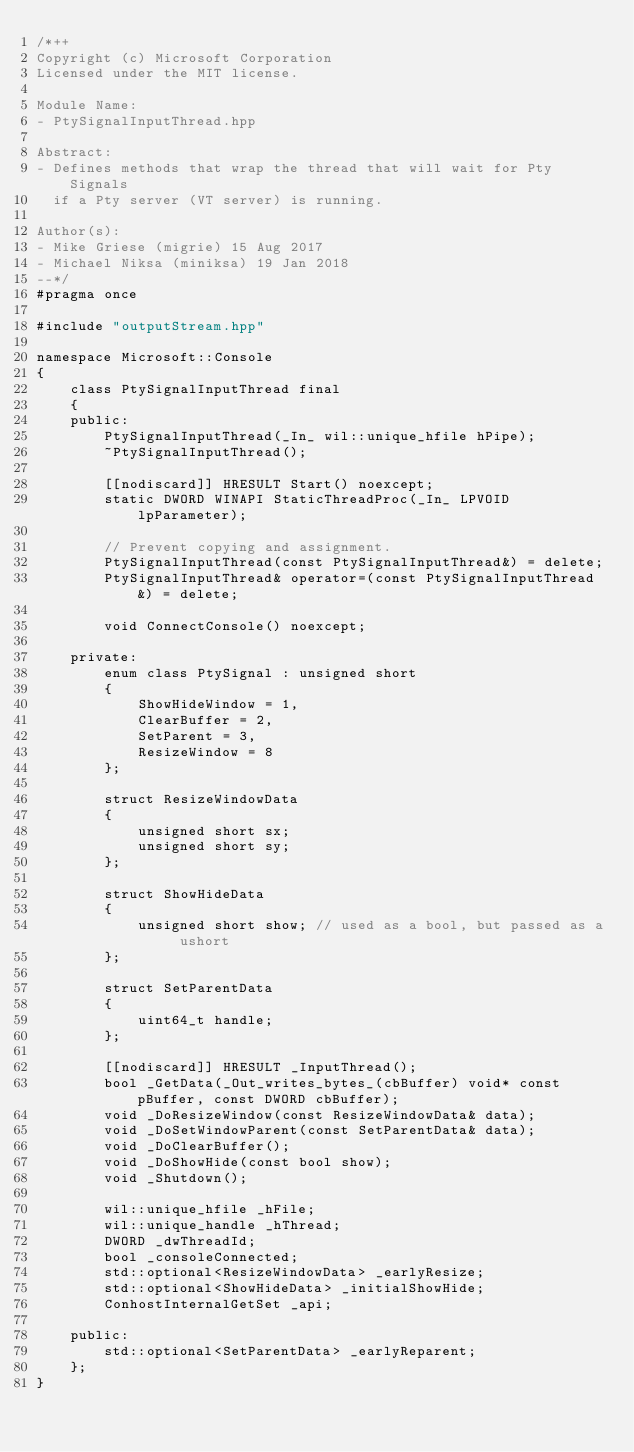Convert code to text. <code><loc_0><loc_0><loc_500><loc_500><_C++_>/*++
Copyright (c) Microsoft Corporation
Licensed under the MIT license.

Module Name:
- PtySignalInputThread.hpp

Abstract:
- Defines methods that wrap the thread that will wait for Pty Signals
  if a Pty server (VT server) is running.

Author(s):
- Mike Griese (migrie) 15 Aug 2017
- Michael Niksa (miniksa) 19 Jan 2018
--*/
#pragma once

#include "outputStream.hpp"

namespace Microsoft::Console
{
    class PtySignalInputThread final
    {
    public:
        PtySignalInputThread(_In_ wil::unique_hfile hPipe);
        ~PtySignalInputThread();

        [[nodiscard]] HRESULT Start() noexcept;
        static DWORD WINAPI StaticThreadProc(_In_ LPVOID lpParameter);

        // Prevent copying and assignment.
        PtySignalInputThread(const PtySignalInputThread&) = delete;
        PtySignalInputThread& operator=(const PtySignalInputThread&) = delete;

        void ConnectConsole() noexcept;

    private:
        enum class PtySignal : unsigned short
        {
            ShowHideWindow = 1,
            ClearBuffer = 2,
            SetParent = 3,
            ResizeWindow = 8
        };

        struct ResizeWindowData
        {
            unsigned short sx;
            unsigned short sy;
        };

        struct ShowHideData
        {
            unsigned short show; // used as a bool, but passed as a ushort
        };

        struct SetParentData
        {
            uint64_t handle;
        };

        [[nodiscard]] HRESULT _InputThread();
        bool _GetData(_Out_writes_bytes_(cbBuffer) void* const pBuffer, const DWORD cbBuffer);
        void _DoResizeWindow(const ResizeWindowData& data);
        void _DoSetWindowParent(const SetParentData& data);
        void _DoClearBuffer();
        void _DoShowHide(const bool show);
        void _Shutdown();

        wil::unique_hfile _hFile;
        wil::unique_handle _hThread;
        DWORD _dwThreadId;
        bool _consoleConnected;
        std::optional<ResizeWindowData> _earlyResize;
        std::optional<ShowHideData> _initialShowHide;
        ConhostInternalGetSet _api;

    public:
        std::optional<SetParentData> _earlyReparent;
    };
}
</code> 